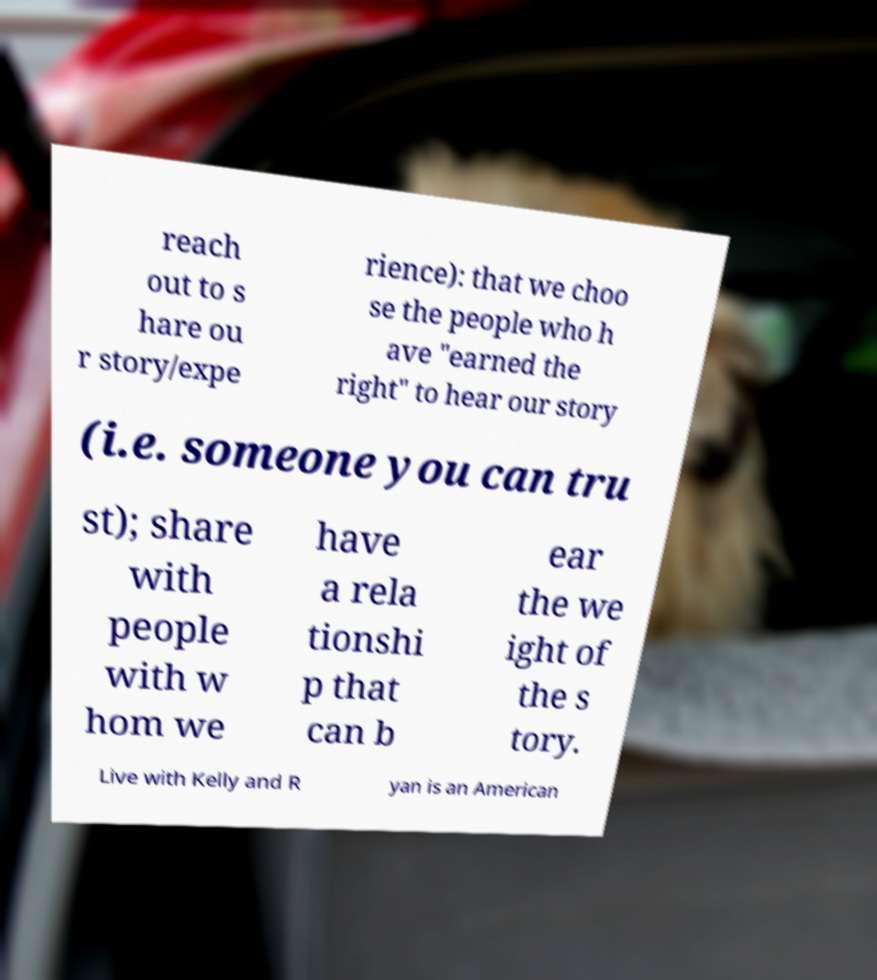What messages or text are displayed in this image? I need them in a readable, typed format. reach out to s hare ou r story/expe rience): that we choo se the people who h ave "earned the right" to hear our story (i.e. someone you can tru st); share with people with w hom we have a rela tionshi p that can b ear the we ight of the s tory. Live with Kelly and R yan is an American 